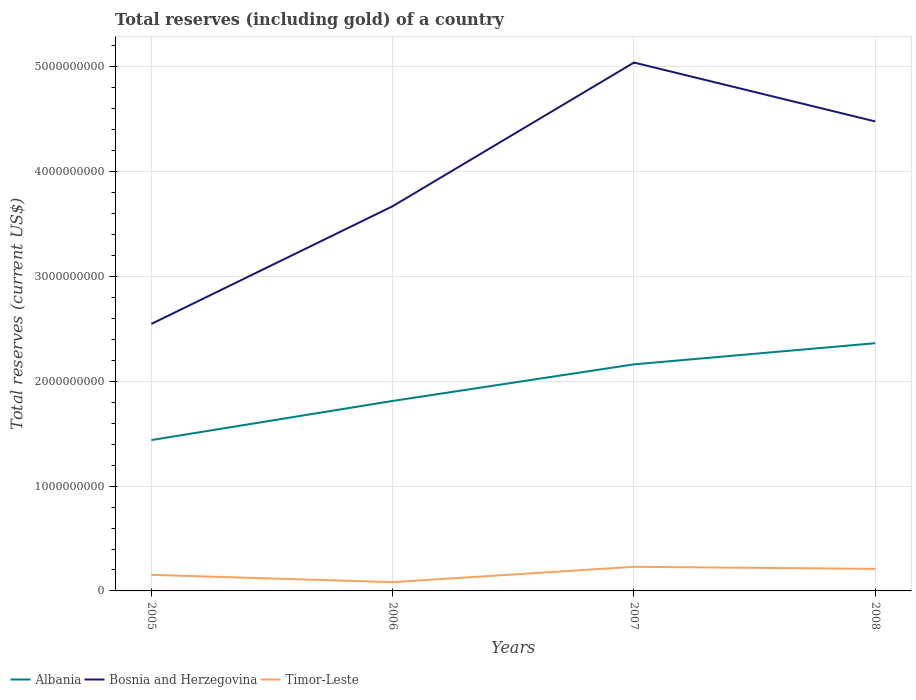Is the number of lines equal to the number of legend labels?
Offer a very short reply. Yes. Across all years, what is the maximum total reserves (including gold) in Bosnia and Herzegovina?
Keep it short and to the point. 2.55e+09. In which year was the total reserves (including gold) in Albania maximum?
Keep it short and to the point. 2005. What is the total total reserves (including gold) in Timor-Leste in the graph?
Provide a succinct answer. 1.98e+07. What is the difference between the highest and the second highest total reserves (including gold) in Timor-Leste?
Offer a terse response. 1.47e+08. Is the total reserves (including gold) in Bosnia and Herzegovina strictly greater than the total reserves (including gold) in Timor-Leste over the years?
Offer a very short reply. No. How many lines are there?
Offer a very short reply. 3. How many years are there in the graph?
Offer a very short reply. 4. What is the difference between two consecutive major ticks on the Y-axis?
Provide a short and direct response. 1.00e+09. Are the values on the major ticks of Y-axis written in scientific E-notation?
Give a very brief answer. No. Does the graph contain any zero values?
Offer a terse response. No. Does the graph contain grids?
Provide a short and direct response. Yes. How many legend labels are there?
Keep it short and to the point. 3. What is the title of the graph?
Your response must be concise. Total reserves (including gold) of a country. Does "Small states" appear as one of the legend labels in the graph?
Provide a short and direct response. No. What is the label or title of the X-axis?
Provide a succinct answer. Years. What is the label or title of the Y-axis?
Your answer should be compact. Total reserves (current US$). What is the Total reserves (current US$) of Albania in 2005?
Give a very brief answer. 1.44e+09. What is the Total reserves (current US$) in Bosnia and Herzegovina in 2005?
Give a very brief answer. 2.55e+09. What is the Total reserves (current US$) in Timor-Leste in 2005?
Offer a terse response. 1.53e+08. What is the Total reserves (current US$) in Albania in 2006?
Give a very brief answer. 1.81e+09. What is the Total reserves (current US$) of Bosnia and Herzegovina in 2006?
Give a very brief answer. 3.67e+09. What is the Total reserves (current US$) in Timor-Leste in 2006?
Provide a short and direct response. 8.38e+07. What is the Total reserves (current US$) in Albania in 2007?
Make the answer very short. 2.16e+09. What is the Total reserves (current US$) in Bosnia and Herzegovina in 2007?
Give a very brief answer. 5.04e+09. What is the Total reserves (current US$) of Timor-Leste in 2007?
Your answer should be compact. 2.30e+08. What is the Total reserves (current US$) in Albania in 2008?
Keep it short and to the point. 2.36e+09. What is the Total reserves (current US$) of Bosnia and Herzegovina in 2008?
Offer a terse response. 4.48e+09. What is the Total reserves (current US$) of Timor-Leste in 2008?
Make the answer very short. 2.10e+08. Across all years, what is the maximum Total reserves (current US$) of Albania?
Keep it short and to the point. 2.36e+09. Across all years, what is the maximum Total reserves (current US$) in Bosnia and Herzegovina?
Provide a succinct answer. 5.04e+09. Across all years, what is the maximum Total reserves (current US$) in Timor-Leste?
Your answer should be very brief. 2.30e+08. Across all years, what is the minimum Total reserves (current US$) in Albania?
Ensure brevity in your answer.  1.44e+09. Across all years, what is the minimum Total reserves (current US$) in Bosnia and Herzegovina?
Your response must be concise. 2.55e+09. Across all years, what is the minimum Total reserves (current US$) of Timor-Leste?
Provide a succinct answer. 8.38e+07. What is the total Total reserves (current US$) in Albania in the graph?
Ensure brevity in your answer.  7.78e+09. What is the total Total reserves (current US$) of Bosnia and Herzegovina in the graph?
Ensure brevity in your answer.  1.57e+1. What is the total Total reserves (current US$) of Timor-Leste in the graph?
Give a very brief answer. 6.78e+08. What is the difference between the Total reserves (current US$) of Albania in 2005 and that in 2006?
Provide a short and direct response. -3.73e+08. What is the difference between the Total reserves (current US$) of Bosnia and Herzegovina in 2005 and that in 2006?
Your response must be concise. -1.12e+09. What is the difference between the Total reserves (current US$) in Timor-Leste in 2005 and that in 2006?
Ensure brevity in your answer.  6.95e+07. What is the difference between the Total reserves (current US$) of Albania in 2005 and that in 2007?
Provide a short and direct response. -7.22e+08. What is the difference between the Total reserves (current US$) of Bosnia and Herzegovina in 2005 and that in 2007?
Your answer should be compact. -2.49e+09. What is the difference between the Total reserves (current US$) of Timor-Leste in 2005 and that in 2007?
Offer a very short reply. -7.70e+07. What is the difference between the Total reserves (current US$) in Albania in 2005 and that in 2008?
Provide a succinct answer. -9.24e+08. What is the difference between the Total reserves (current US$) in Bosnia and Herzegovina in 2005 and that in 2008?
Ensure brevity in your answer.  -1.93e+09. What is the difference between the Total reserves (current US$) in Timor-Leste in 2005 and that in 2008?
Provide a short and direct response. -5.71e+07. What is the difference between the Total reserves (current US$) in Albania in 2006 and that in 2007?
Your response must be concise. -3.49e+08. What is the difference between the Total reserves (current US$) in Bosnia and Herzegovina in 2006 and that in 2007?
Make the answer very short. -1.37e+09. What is the difference between the Total reserves (current US$) of Timor-Leste in 2006 and that in 2007?
Keep it short and to the point. -1.47e+08. What is the difference between the Total reserves (current US$) of Albania in 2006 and that in 2008?
Give a very brief answer. -5.51e+08. What is the difference between the Total reserves (current US$) of Bosnia and Herzegovina in 2006 and that in 2008?
Ensure brevity in your answer.  -8.09e+08. What is the difference between the Total reserves (current US$) in Timor-Leste in 2006 and that in 2008?
Provide a short and direct response. -1.27e+08. What is the difference between the Total reserves (current US$) of Albania in 2007 and that in 2008?
Provide a succinct answer. -2.02e+08. What is the difference between the Total reserves (current US$) in Bosnia and Herzegovina in 2007 and that in 2008?
Ensure brevity in your answer.  5.62e+08. What is the difference between the Total reserves (current US$) of Timor-Leste in 2007 and that in 2008?
Your answer should be very brief. 1.98e+07. What is the difference between the Total reserves (current US$) in Albania in 2005 and the Total reserves (current US$) in Bosnia and Herzegovina in 2006?
Keep it short and to the point. -2.23e+09. What is the difference between the Total reserves (current US$) in Albania in 2005 and the Total reserves (current US$) in Timor-Leste in 2006?
Make the answer very short. 1.36e+09. What is the difference between the Total reserves (current US$) in Bosnia and Herzegovina in 2005 and the Total reserves (current US$) in Timor-Leste in 2006?
Provide a succinct answer. 2.46e+09. What is the difference between the Total reserves (current US$) of Albania in 2005 and the Total reserves (current US$) of Bosnia and Herzegovina in 2007?
Provide a succinct answer. -3.60e+09. What is the difference between the Total reserves (current US$) in Albania in 2005 and the Total reserves (current US$) in Timor-Leste in 2007?
Your answer should be compact. 1.21e+09. What is the difference between the Total reserves (current US$) of Bosnia and Herzegovina in 2005 and the Total reserves (current US$) of Timor-Leste in 2007?
Provide a short and direct response. 2.32e+09. What is the difference between the Total reserves (current US$) in Albania in 2005 and the Total reserves (current US$) in Bosnia and Herzegovina in 2008?
Your response must be concise. -3.04e+09. What is the difference between the Total reserves (current US$) in Albania in 2005 and the Total reserves (current US$) in Timor-Leste in 2008?
Ensure brevity in your answer.  1.23e+09. What is the difference between the Total reserves (current US$) in Bosnia and Herzegovina in 2005 and the Total reserves (current US$) in Timor-Leste in 2008?
Make the answer very short. 2.34e+09. What is the difference between the Total reserves (current US$) of Albania in 2006 and the Total reserves (current US$) of Bosnia and Herzegovina in 2007?
Provide a short and direct response. -3.23e+09. What is the difference between the Total reserves (current US$) in Albania in 2006 and the Total reserves (current US$) in Timor-Leste in 2007?
Provide a succinct answer. 1.58e+09. What is the difference between the Total reserves (current US$) of Bosnia and Herzegovina in 2006 and the Total reserves (current US$) of Timor-Leste in 2007?
Your response must be concise. 3.44e+09. What is the difference between the Total reserves (current US$) of Albania in 2006 and the Total reserves (current US$) of Bosnia and Herzegovina in 2008?
Offer a very short reply. -2.67e+09. What is the difference between the Total reserves (current US$) in Albania in 2006 and the Total reserves (current US$) in Timor-Leste in 2008?
Your answer should be very brief. 1.60e+09. What is the difference between the Total reserves (current US$) in Bosnia and Herzegovina in 2006 and the Total reserves (current US$) in Timor-Leste in 2008?
Your response must be concise. 3.46e+09. What is the difference between the Total reserves (current US$) in Albania in 2007 and the Total reserves (current US$) in Bosnia and Herzegovina in 2008?
Your answer should be compact. -2.32e+09. What is the difference between the Total reserves (current US$) in Albania in 2007 and the Total reserves (current US$) in Timor-Leste in 2008?
Offer a very short reply. 1.95e+09. What is the difference between the Total reserves (current US$) in Bosnia and Herzegovina in 2007 and the Total reserves (current US$) in Timor-Leste in 2008?
Keep it short and to the point. 4.83e+09. What is the average Total reserves (current US$) of Albania per year?
Provide a succinct answer. 1.94e+09. What is the average Total reserves (current US$) of Bosnia and Herzegovina per year?
Provide a succinct answer. 3.94e+09. What is the average Total reserves (current US$) in Timor-Leste per year?
Provide a short and direct response. 1.69e+08. In the year 2005, what is the difference between the Total reserves (current US$) of Albania and Total reserves (current US$) of Bosnia and Herzegovina?
Ensure brevity in your answer.  -1.11e+09. In the year 2005, what is the difference between the Total reserves (current US$) in Albania and Total reserves (current US$) in Timor-Leste?
Provide a short and direct response. 1.29e+09. In the year 2005, what is the difference between the Total reserves (current US$) of Bosnia and Herzegovina and Total reserves (current US$) of Timor-Leste?
Offer a terse response. 2.39e+09. In the year 2006, what is the difference between the Total reserves (current US$) in Albania and Total reserves (current US$) in Bosnia and Herzegovina?
Your answer should be compact. -1.86e+09. In the year 2006, what is the difference between the Total reserves (current US$) of Albania and Total reserves (current US$) of Timor-Leste?
Give a very brief answer. 1.73e+09. In the year 2006, what is the difference between the Total reserves (current US$) of Bosnia and Herzegovina and Total reserves (current US$) of Timor-Leste?
Provide a short and direct response. 3.59e+09. In the year 2007, what is the difference between the Total reserves (current US$) in Albania and Total reserves (current US$) in Bosnia and Herzegovina?
Provide a succinct answer. -2.88e+09. In the year 2007, what is the difference between the Total reserves (current US$) in Albania and Total reserves (current US$) in Timor-Leste?
Provide a succinct answer. 1.93e+09. In the year 2007, what is the difference between the Total reserves (current US$) of Bosnia and Herzegovina and Total reserves (current US$) of Timor-Leste?
Provide a succinct answer. 4.81e+09. In the year 2008, what is the difference between the Total reserves (current US$) in Albania and Total reserves (current US$) in Bosnia and Herzegovina?
Your response must be concise. -2.12e+09. In the year 2008, what is the difference between the Total reserves (current US$) in Albania and Total reserves (current US$) in Timor-Leste?
Offer a terse response. 2.15e+09. In the year 2008, what is the difference between the Total reserves (current US$) of Bosnia and Herzegovina and Total reserves (current US$) of Timor-Leste?
Your response must be concise. 4.27e+09. What is the ratio of the Total reserves (current US$) in Albania in 2005 to that in 2006?
Ensure brevity in your answer.  0.79. What is the ratio of the Total reserves (current US$) in Bosnia and Herzegovina in 2005 to that in 2006?
Ensure brevity in your answer.  0.69. What is the ratio of the Total reserves (current US$) of Timor-Leste in 2005 to that in 2006?
Offer a terse response. 1.83. What is the ratio of the Total reserves (current US$) in Albania in 2005 to that in 2007?
Make the answer very short. 0.67. What is the ratio of the Total reserves (current US$) in Bosnia and Herzegovina in 2005 to that in 2007?
Your answer should be very brief. 0.51. What is the ratio of the Total reserves (current US$) in Timor-Leste in 2005 to that in 2007?
Give a very brief answer. 0.67. What is the ratio of the Total reserves (current US$) in Albania in 2005 to that in 2008?
Provide a succinct answer. 0.61. What is the ratio of the Total reserves (current US$) in Bosnia and Herzegovina in 2005 to that in 2008?
Ensure brevity in your answer.  0.57. What is the ratio of the Total reserves (current US$) in Timor-Leste in 2005 to that in 2008?
Your answer should be very brief. 0.73. What is the ratio of the Total reserves (current US$) in Albania in 2006 to that in 2007?
Provide a succinct answer. 0.84. What is the ratio of the Total reserves (current US$) of Bosnia and Herzegovina in 2006 to that in 2007?
Offer a very short reply. 0.73. What is the ratio of the Total reserves (current US$) in Timor-Leste in 2006 to that in 2007?
Offer a terse response. 0.36. What is the ratio of the Total reserves (current US$) of Albania in 2006 to that in 2008?
Your answer should be very brief. 0.77. What is the ratio of the Total reserves (current US$) in Bosnia and Herzegovina in 2006 to that in 2008?
Offer a terse response. 0.82. What is the ratio of the Total reserves (current US$) in Timor-Leste in 2006 to that in 2008?
Your response must be concise. 0.4. What is the ratio of the Total reserves (current US$) of Albania in 2007 to that in 2008?
Your answer should be compact. 0.91. What is the ratio of the Total reserves (current US$) in Bosnia and Herzegovina in 2007 to that in 2008?
Offer a very short reply. 1.13. What is the ratio of the Total reserves (current US$) in Timor-Leste in 2007 to that in 2008?
Keep it short and to the point. 1.09. What is the difference between the highest and the second highest Total reserves (current US$) of Albania?
Your answer should be very brief. 2.02e+08. What is the difference between the highest and the second highest Total reserves (current US$) in Bosnia and Herzegovina?
Your response must be concise. 5.62e+08. What is the difference between the highest and the second highest Total reserves (current US$) of Timor-Leste?
Keep it short and to the point. 1.98e+07. What is the difference between the highest and the lowest Total reserves (current US$) of Albania?
Provide a succinct answer. 9.24e+08. What is the difference between the highest and the lowest Total reserves (current US$) in Bosnia and Herzegovina?
Offer a terse response. 2.49e+09. What is the difference between the highest and the lowest Total reserves (current US$) of Timor-Leste?
Your answer should be compact. 1.47e+08. 